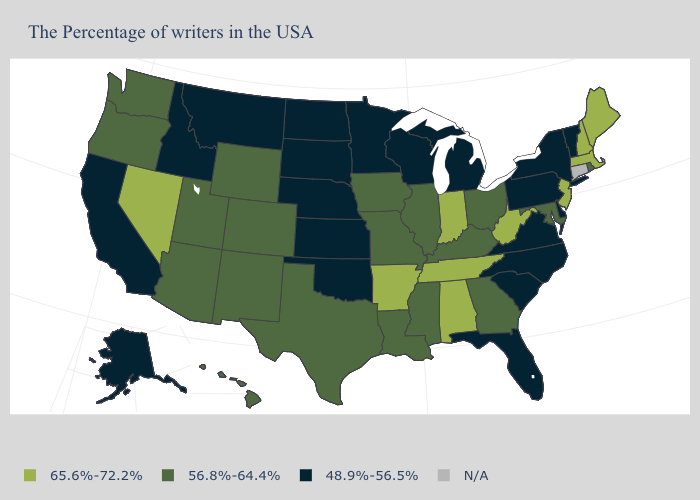What is the highest value in the USA?
Write a very short answer. 65.6%-72.2%. Which states have the lowest value in the USA?
Concise answer only. Vermont, New York, Delaware, Pennsylvania, Virginia, North Carolina, South Carolina, Florida, Michigan, Wisconsin, Minnesota, Kansas, Nebraska, Oklahoma, South Dakota, North Dakota, Montana, Idaho, California, Alaska. Among the states that border Kansas , does Colorado have the highest value?
Write a very short answer. Yes. Among the states that border New Jersey , which have the highest value?
Answer briefly. New York, Delaware, Pennsylvania. Is the legend a continuous bar?
Be succinct. No. Name the states that have a value in the range 65.6%-72.2%?
Short answer required. Maine, Massachusetts, New Hampshire, New Jersey, West Virginia, Indiana, Alabama, Tennessee, Arkansas, Nevada. What is the lowest value in the USA?
Concise answer only. 48.9%-56.5%. What is the value of Arizona?
Give a very brief answer. 56.8%-64.4%. Which states have the lowest value in the USA?
Keep it brief. Vermont, New York, Delaware, Pennsylvania, Virginia, North Carolina, South Carolina, Florida, Michigan, Wisconsin, Minnesota, Kansas, Nebraska, Oklahoma, South Dakota, North Dakota, Montana, Idaho, California, Alaska. Name the states that have a value in the range N/A?
Keep it brief. Connecticut. Among the states that border Maryland , which have the highest value?
Be succinct. West Virginia. Does Arkansas have the lowest value in the South?
Write a very short answer. No. What is the value of Arkansas?
Write a very short answer. 65.6%-72.2%. 